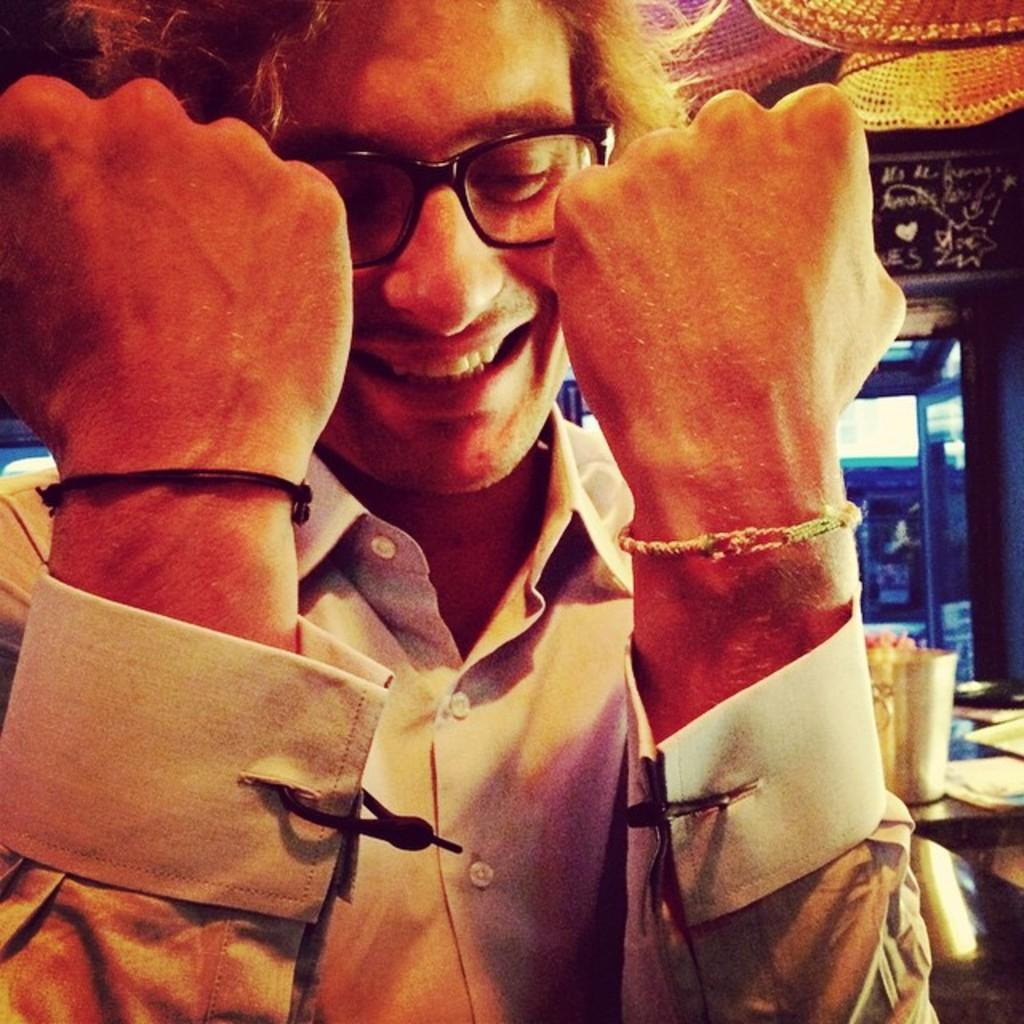Who is present in the image? There is a man in the image. What is the man's facial expression? The man is smiling. What accessory is the man wearing? The man is wearing spectacles. What can be seen in the background of the image? There is a glass, objects on a table, hats, a door, and a wall in the background of the image. What type of alarm is ringing in the image? There is no alarm present in the image. What list can be seen on the table in the image? There is no list visible on the table in the image. 